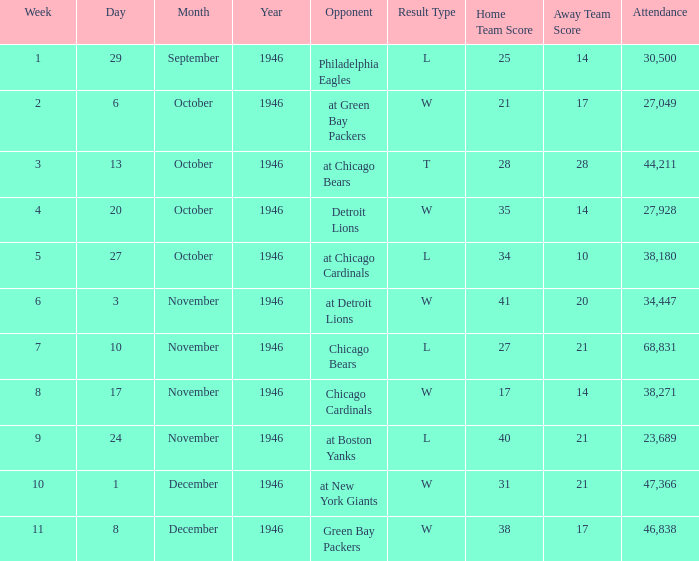What is the combined attendance of all games that had a result of w 35-14? 27928.0. 